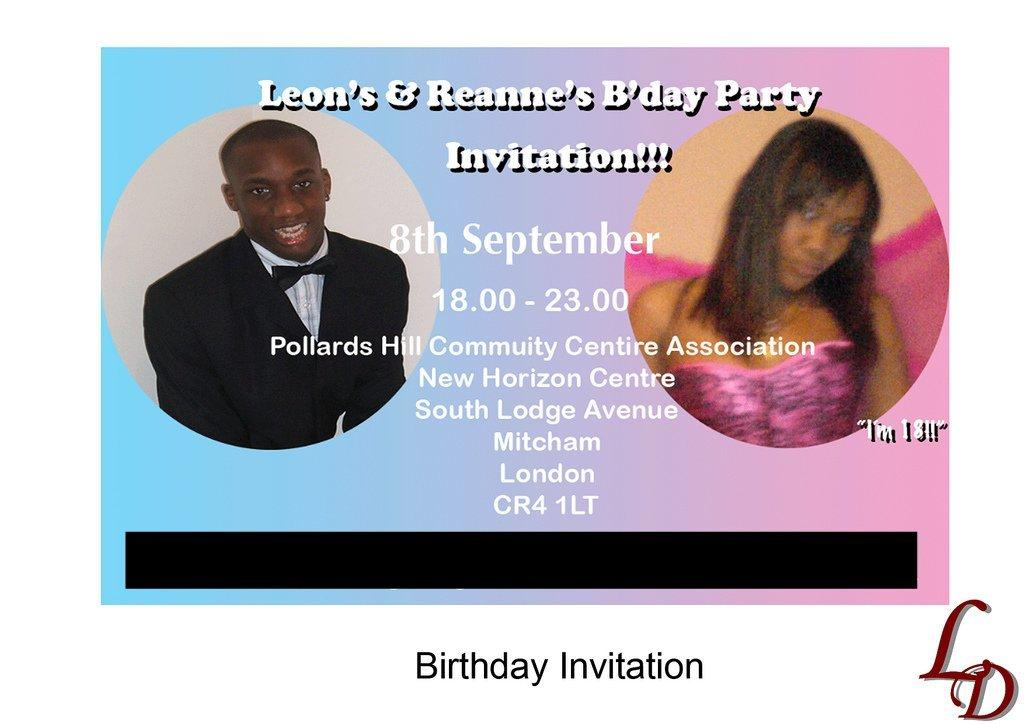What can be seen in the image? There are pictures of persons in the image. What else is present in the image besides the pictures of persons? There is writing on the image. What type of bells can be heard ringing in the image? There are no bells present in the image, and therefore no sound can be heard. 